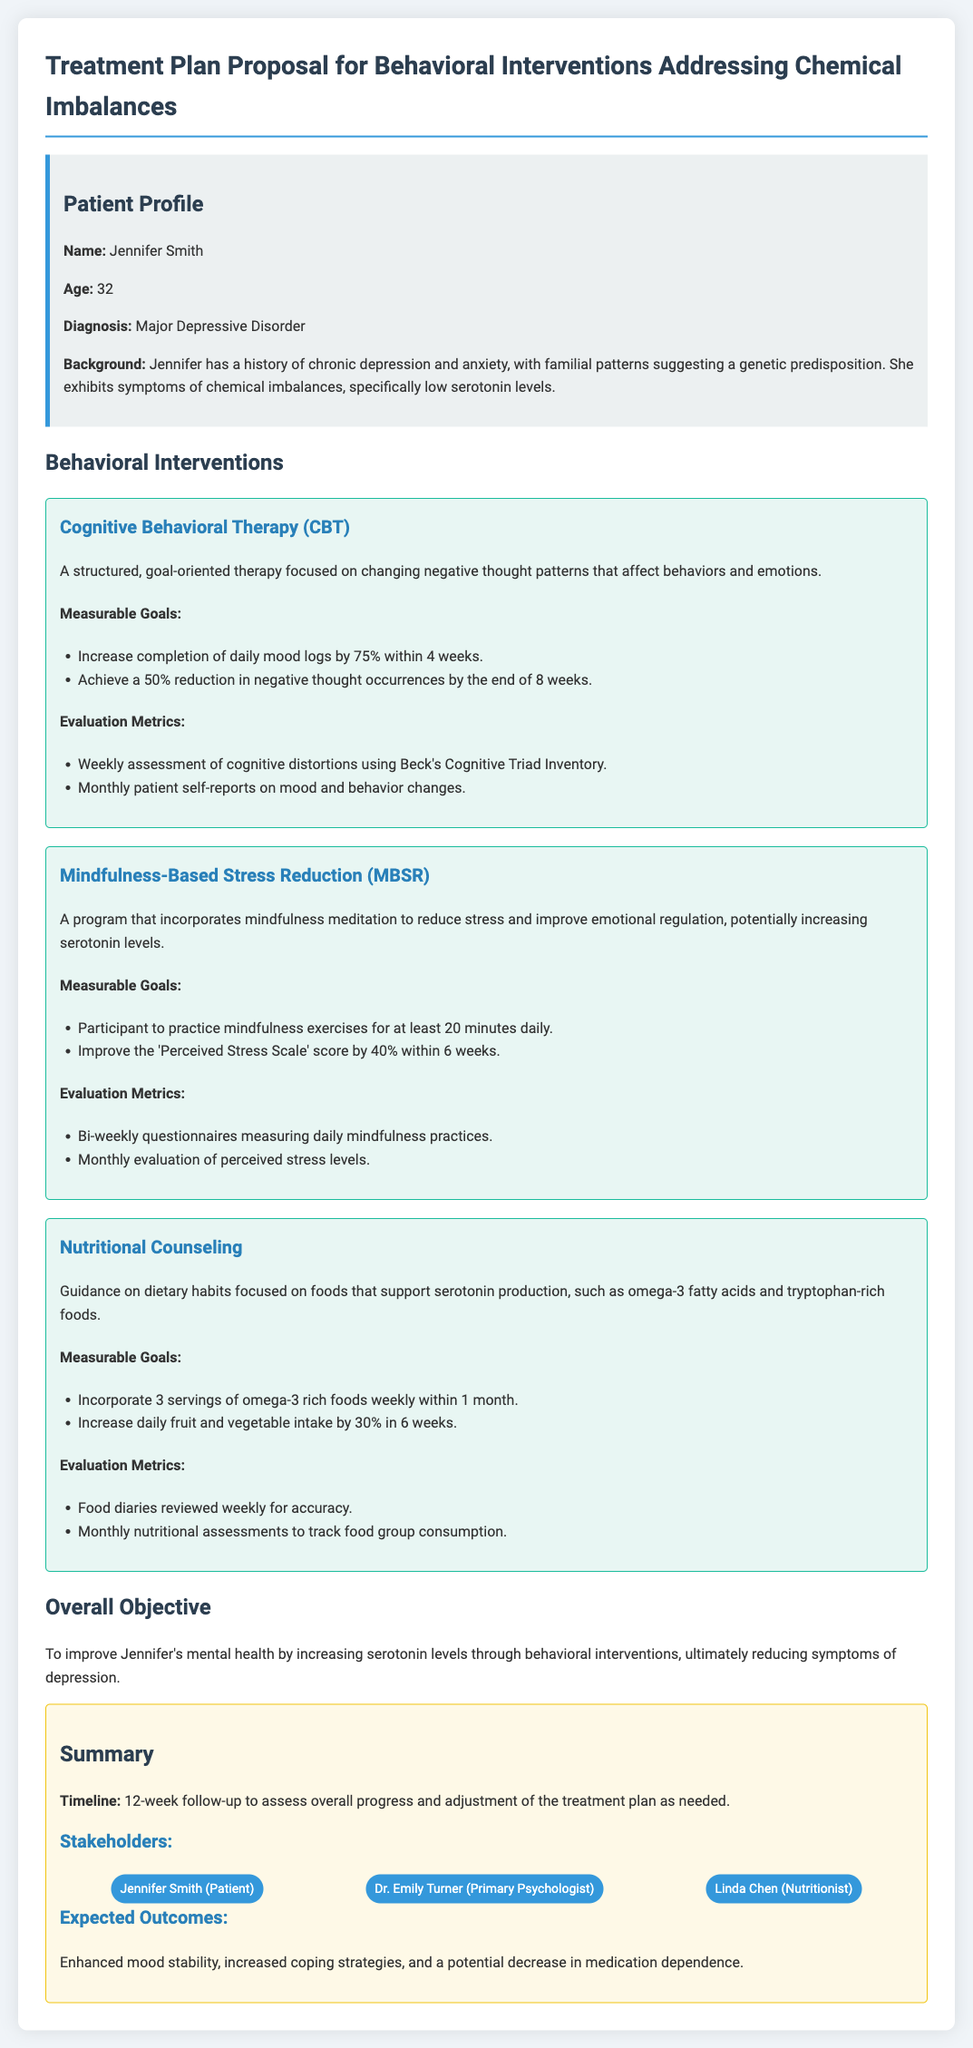What is the patient's name? The patient's name is mentioned in the patient profile section of the document.
Answer: Jennifer Smith What is the patient's age? The age of the patient is provided in the patient profile section.
Answer: 32 What is the primary psychological intervention listed? The primary intervention focuses on changing negative thought patterns, which is specified in the behavioral interventions section.
Answer: Cognitive Behavioral Therapy (CBT) What measurable goal is associated with Nutritional Counseling? One of the goals under Nutritional Counseling is stated in the list of measurable goals.
Answer: Incorporate 3 servings of omega-3 rich foods weekly within 1 month By what percentage does MBSR aim to improve the 'Perceived Stress Scale' score? The specific percentage improvement goal is specified under the measurable goals of MBSR.
Answer: 40% How often will food diaries be reviewed in Nutritional Counseling? The review frequency of food diaries is noted in the evaluation metrics of Nutritional Counseling.
Answer: Weekly What is the overall objective of the treatment plan? The overall objective summarizes the main aim of the treatment proposal.
Answer: To improve Jennifer's mental health by increasing serotonin levels What is the timeline for follow-up assessment mentioned? The document states a timeline for assessing overall progress after a specific period.
Answer: 12-week follow-up Who is the nutritionist involved in the treatment plan? The nutritionist's name is given in the stakeholders section of the document.
Answer: Linda Chen 